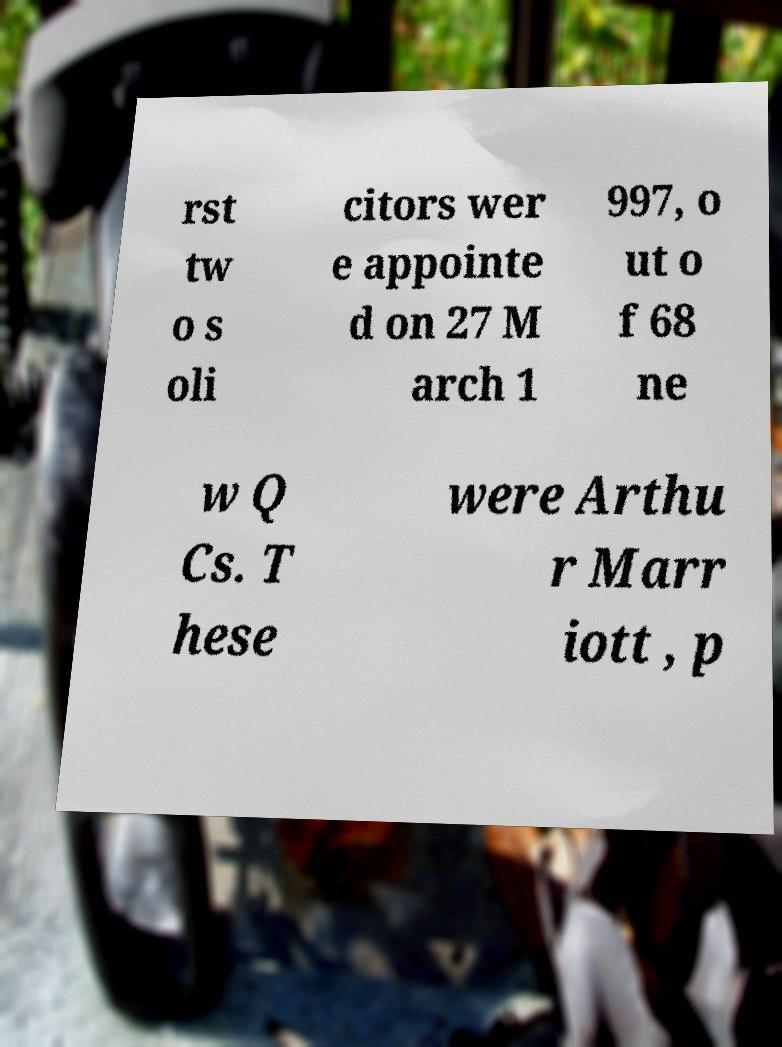Please identify and transcribe the text found in this image. rst tw o s oli citors wer e appointe d on 27 M arch 1 997, o ut o f 68 ne w Q Cs. T hese were Arthu r Marr iott , p 